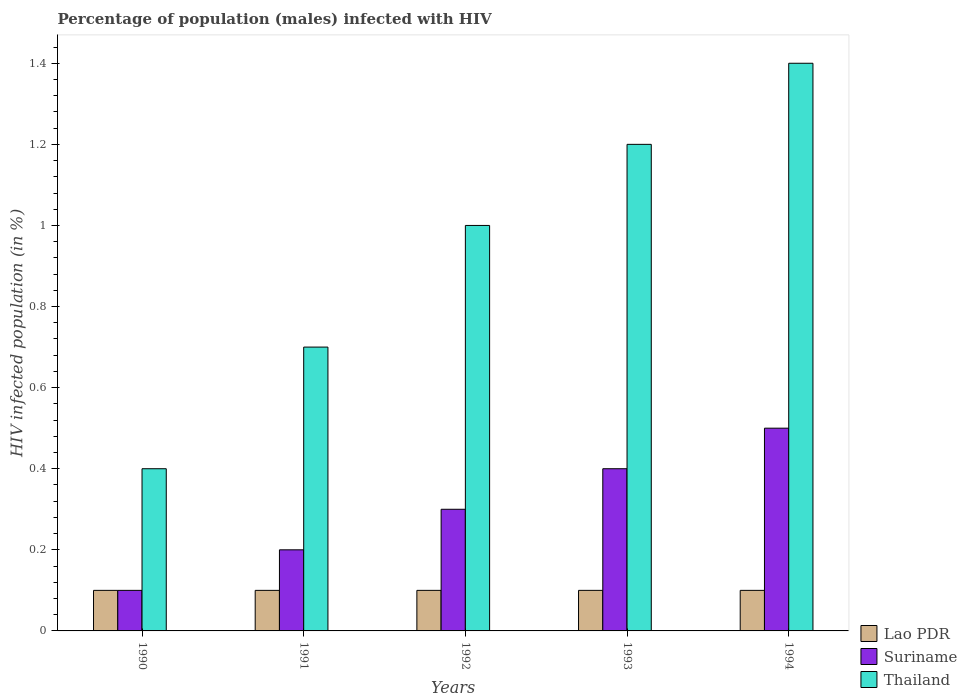How many groups of bars are there?
Give a very brief answer. 5. How many bars are there on the 4th tick from the left?
Ensure brevity in your answer.  3. How many bars are there on the 4th tick from the right?
Ensure brevity in your answer.  3. What is the label of the 2nd group of bars from the left?
Provide a short and direct response. 1991. In how many cases, is the number of bars for a given year not equal to the number of legend labels?
Ensure brevity in your answer.  0. Across all years, what is the maximum percentage of HIV infected male population in Thailand?
Your response must be concise. 1.4. What is the total percentage of HIV infected male population in Suriname in the graph?
Keep it short and to the point. 1.5. What is the difference between the percentage of HIV infected male population in Suriname in 1993 and that in 1994?
Provide a succinct answer. -0.1. What is the difference between the percentage of HIV infected male population in Suriname in 1992 and the percentage of HIV infected male population in Lao PDR in 1990?
Make the answer very short. 0.2. What is the average percentage of HIV infected male population in Thailand per year?
Offer a very short reply. 0.94. In the year 1994, what is the difference between the percentage of HIV infected male population in Lao PDR and percentage of HIV infected male population in Thailand?
Offer a terse response. -1.3. What is the ratio of the percentage of HIV infected male population in Thailand in 1992 to that in 1994?
Ensure brevity in your answer.  0.71. Is the percentage of HIV infected male population in Thailand in 1993 less than that in 1994?
Ensure brevity in your answer.  Yes. What is the difference between the highest and the lowest percentage of HIV infected male population in Suriname?
Keep it short and to the point. 0.4. What does the 2nd bar from the left in 1993 represents?
Offer a terse response. Suriname. What does the 3rd bar from the right in 1993 represents?
Your response must be concise. Lao PDR. How many years are there in the graph?
Keep it short and to the point. 5. What is the difference between two consecutive major ticks on the Y-axis?
Ensure brevity in your answer.  0.2. How are the legend labels stacked?
Provide a short and direct response. Vertical. What is the title of the graph?
Offer a terse response. Percentage of population (males) infected with HIV. What is the label or title of the X-axis?
Offer a very short reply. Years. What is the label or title of the Y-axis?
Your response must be concise. HIV infected population (in %). What is the HIV infected population (in %) of Thailand in 1990?
Your response must be concise. 0.4. What is the HIV infected population (in %) in Lao PDR in 1991?
Keep it short and to the point. 0.1. What is the HIV infected population (in %) in Thailand in 1991?
Give a very brief answer. 0.7. What is the HIV infected population (in %) of Lao PDR in 1992?
Your answer should be compact. 0.1. What is the HIV infected population (in %) in Lao PDR in 1993?
Your response must be concise. 0.1. What is the HIV infected population (in %) of Suriname in 1994?
Your answer should be very brief. 0.5. What is the HIV infected population (in %) in Thailand in 1994?
Provide a short and direct response. 1.4. Across all years, what is the maximum HIV infected population (in %) of Lao PDR?
Make the answer very short. 0.1. Across all years, what is the maximum HIV infected population (in %) in Suriname?
Make the answer very short. 0.5. Across all years, what is the maximum HIV infected population (in %) of Thailand?
Provide a succinct answer. 1.4. Across all years, what is the minimum HIV infected population (in %) of Lao PDR?
Provide a succinct answer. 0.1. Across all years, what is the minimum HIV infected population (in %) of Suriname?
Your answer should be compact. 0.1. What is the total HIV infected population (in %) of Suriname in the graph?
Your answer should be very brief. 1.5. What is the total HIV infected population (in %) of Thailand in the graph?
Offer a terse response. 4.7. What is the difference between the HIV infected population (in %) in Thailand in 1990 and that in 1991?
Keep it short and to the point. -0.3. What is the difference between the HIV infected population (in %) of Lao PDR in 1990 and that in 1992?
Provide a short and direct response. 0. What is the difference between the HIV infected population (in %) in Suriname in 1990 and that in 1992?
Provide a succinct answer. -0.2. What is the difference between the HIV infected population (in %) of Thailand in 1990 and that in 1992?
Give a very brief answer. -0.6. What is the difference between the HIV infected population (in %) in Lao PDR in 1990 and that in 1993?
Provide a succinct answer. 0. What is the difference between the HIV infected population (in %) in Suriname in 1990 and that in 1993?
Provide a short and direct response. -0.3. What is the difference between the HIV infected population (in %) of Thailand in 1990 and that in 1994?
Give a very brief answer. -1. What is the difference between the HIV infected population (in %) in Lao PDR in 1991 and that in 1992?
Give a very brief answer. 0. What is the difference between the HIV infected population (in %) in Lao PDR in 1991 and that in 1993?
Offer a terse response. 0. What is the difference between the HIV infected population (in %) in Suriname in 1991 and that in 1993?
Your answer should be very brief. -0.2. What is the difference between the HIV infected population (in %) in Lao PDR in 1991 and that in 1994?
Keep it short and to the point. 0. What is the difference between the HIV infected population (in %) in Lao PDR in 1992 and that in 1993?
Keep it short and to the point. 0. What is the difference between the HIV infected population (in %) in Lao PDR in 1992 and that in 1994?
Provide a succinct answer. 0. What is the difference between the HIV infected population (in %) of Suriname in 1992 and that in 1994?
Give a very brief answer. -0.2. What is the difference between the HIV infected population (in %) in Lao PDR in 1993 and that in 1994?
Ensure brevity in your answer.  0. What is the difference between the HIV infected population (in %) of Thailand in 1993 and that in 1994?
Your answer should be very brief. -0.2. What is the difference between the HIV infected population (in %) of Lao PDR in 1990 and the HIV infected population (in %) of Thailand in 1991?
Keep it short and to the point. -0.6. What is the difference between the HIV infected population (in %) of Suriname in 1990 and the HIV infected population (in %) of Thailand in 1992?
Your answer should be very brief. -0.9. What is the difference between the HIV infected population (in %) in Lao PDR in 1990 and the HIV infected population (in %) in Suriname in 1993?
Keep it short and to the point. -0.3. What is the difference between the HIV infected population (in %) of Suriname in 1990 and the HIV infected population (in %) of Thailand in 1993?
Your answer should be very brief. -1.1. What is the difference between the HIV infected population (in %) in Suriname in 1990 and the HIV infected population (in %) in Thailand in 1994?
Offer a terse response. -1.3. What is the difference between the HIV infected population (in %) of Lao PDR in 1991 and the HIV infected population (in %) of Suriname in 1992?
Offer a very short reply. -0.2. What is the difference between the HIV infected population (in %) of Lao PDR in 1991 and the HIV infected population (in %) of Thailand in 1993?
Your response must be concise. -1.1. What is the difference between the HIV infected population (in %) in Suriname in 1991 and the HIV infected population (in %) in Thailand in 1993?
Offer a very short reply. -1. What is the difference between the HIV infected population (in %) in Lao PDR in 1992 and the HIV infected population (in %) in Thailand in 1993?
Your answer should be very brief. -1.1. What is the difference between the HIV infected population (in %) in Suriname in 1992 and the HIV infected population (in %) in Thailand in 1993?
Your response must be concise. -0.9. What is the difference between the HIV infected population (in %) of Suriname in 1992 and the HIV infected population (in %) of Thailand in 1994?
Your response must be concise. -1.1. What is the difference between the HIV infected population (in %) of Lao PDR in 1993 and the HIV infected population (in %) of Suriname in 1994?
Provide a succinct answer. -0.4. What is the difference between the HIV infected population (in %) in Lao PDR in 1993 and the HIV infected population (in %) in Thailand in 1994?
Make the answer very short. -1.3. What is the average HIV infected population (in %) in Thailand per year?
Your answer should be compact. 0.94. In the year 1990, what is the difference between the HIV infected population (in %) in Lao PDR and HIV infected population (in %) in Suriname?
Make the answer very short. 0. In the year 1990, what is the difference between the HIV infected population (in %) of Lao PDR and HIV infected population (in %) of Thailand?
Ensure brevity in your answer.  -0.3. In the year 1990, what is the difference between the HIV infected population (in %) of Suriname and HIV infected population (in %) of Thailand?
Your answer should be very brief. -0.3. In the year 1991, what is the difference between the HIV infected population (in %) in Lao PDR and HIV infected population (in %) in Thailand?
Your answer should be compact. -0.6. In the year 1993, what is the difference between the HIV infected population (in %) in Lao PDR and HIV infected population (in %) in Suriname?
Make the answer very short. -0.3. In the year 1993, what is the difference between the HIV infected population (in %) in Lao PDR and HIV infected population (in %) in Thailand?
Offer a terse response. -1.1. In the year 1994, what is the difference between the HIV infected population (in %) of Lao PDR and HIV infected population (in %) of Suriname?
Keep it short and to the point. -0.4. In the year 1994, what is the difference between the HIV infected population (in %) in Lao PDR and HIV infected population (in %) in Thailand?
Provide a succinct answer. -1.3. In the year 1994, what is the difference between the HIV infected population (in %) of Suriname and HIV infected population (in %) of Thailand?
Give a very brief answer. -0.9. What is the ratio of the HIV infected population (in %) of Suriname in 1990 to that in 1991?
Ensure brevity in your answer.  0.5. What is the ratio of the HIV infected population (in %) of Thailand in 1990 to that in 1991?
Ensure brevity in your answer.  0.57. What is the ratio of the HIV infected population (in %) in Lao PDR in 1990 to that in 1992?
Provide a short and direct response. 1. What is the ratio of the HIV infected population (in %) of Suriname in 1990 to that in 1992?
Offer a very short reply. 0.33. What is the ratio of the HIV infected population (in %) in Thailand in 1990 to that in 1993?
Keep it short and to the point. 0.33. What is the ratio of the HIV infected population (in %) in Suriname in 1990 to that in 1994?
Give a very brief answer. 0.2. What is the ratio of the HIV infected population (in %) of Thailand in 1990 to that in 1994?
Keep it short and to the point. 0.29. What is the ratio of the HIV infected population (in %) of Suriname in 1991 to that in 1992?
Provide a succinct answer. 0.67. What is the ratio of the HIV infected population (in %) of Lao PDR in 1991 to that in 1993?
Keep it short and to the point. 1. What is the ratio of the HIV infected population (in %) in Thailand in 1991 to that in 1993?
Make the answer very short. 0.58. What is the ratio of the HIV infected population (in %) of Lao PDR in 1991 to that in 1994?
Provide a succinct answer. 1. What is the ratio of the HIV infected population (in %) of Suriname in 1991 to that in 1994?
Give a very brief answer. 0.4. What is the ratio of the HIV infected population (in %) in Suriname in 1992 to that in 1993?
Provide a short and direct response. 0.75. What is the ratio of the HIV infected population (in %) in Suriname in 1992 to that in 1994?
Give a very brief answer. 0.6. What is the ratio of the HIV infected population (in %) in Thailand in 1992 to that in 1994?
Offer a terse response. 0.71. What is the difference between the highest and the second highest HIV infected population (in %) of Lao PDR?
Keep it short and to the point. 0. What is the difference between the highest and the second highest HIV infected population (in %) in Suriname?
Your answer should be very brief. 0.1. What is the difference between the highest and the second highest HIV infected population (in %) of Thailand?
Provide a succinct answer. 0.2. What is the difference between the highest and the lowest HIV infected population (in %) in Lao PDR?
Offer a terse response. 0. What is the difference between the highest and the lowest HIV infected population (in %) in Suriname?
Make the answer very short. 0.4. 